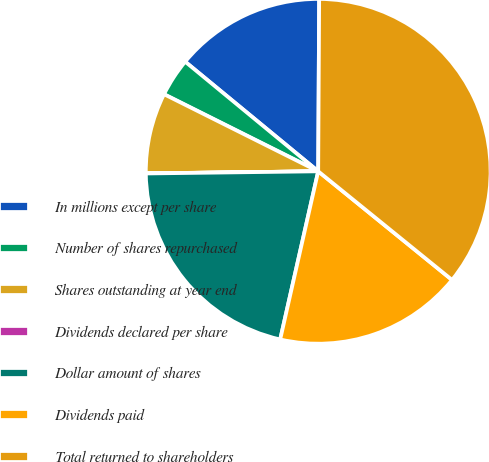Convert chart to OTSL. <chart><loc_0><loc_0><loc_500><loc_500><pie_chart><fcel>In millions except per share<fcel>Number of shares repurchased<fcel>Shares outstanding at year end<fcel>Dividends declared per share<fcel>Dollar amount of shares<fcel>Dividends paid<fcel>Total returned to shareholders<nl><fcel>14.12%<fcel>3.59%<fcel>7.57%<fcel>0.01%<fcel>21.26%<fcel>17.69%<fcel>35.76%<nl></chart> 